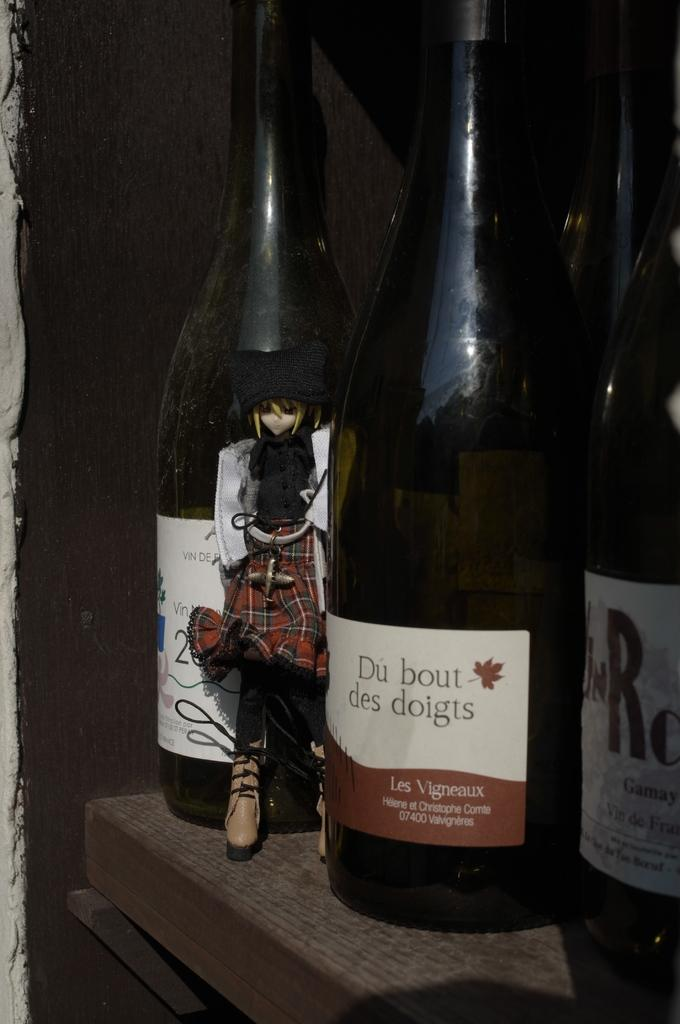Provide a one-sentence caption for the provided image. Three bottles of wine next to each other with the middle bottle saying Du Bout des doigts on the labe. 